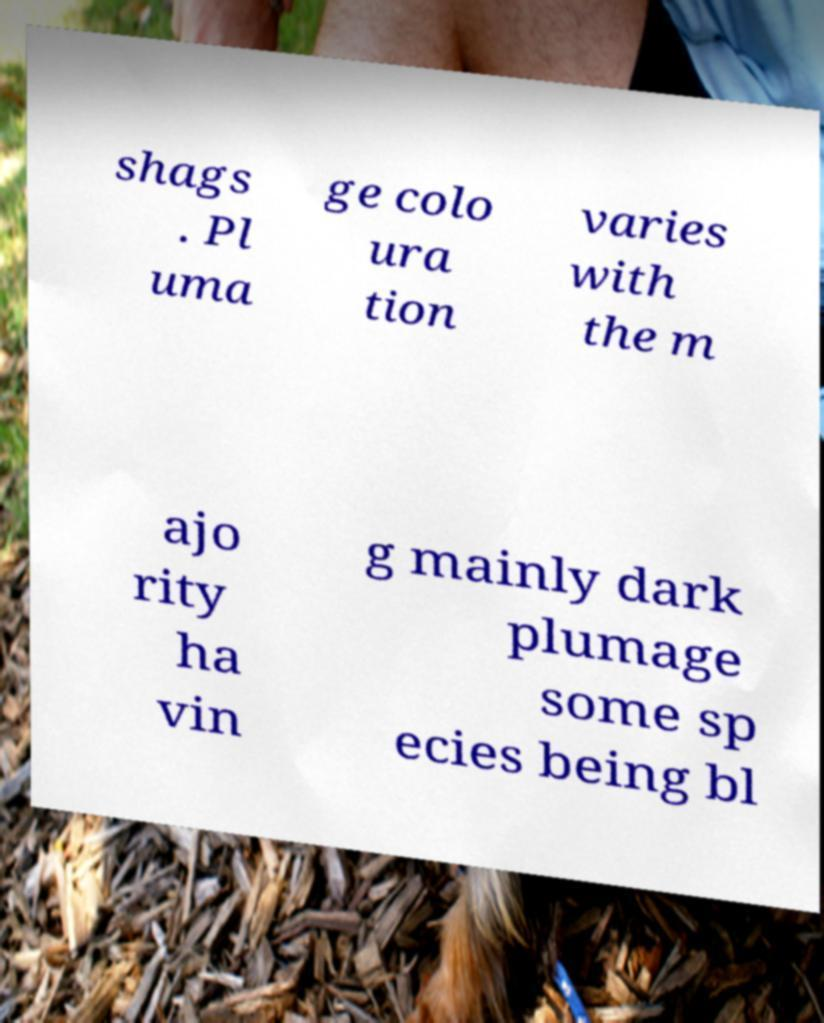Could you assist in decoding the text presented in this image and type it out clearly? shags . Pl uma ge colo ura tion varies with the m ajo rity ha vin g mainly dark plumage some sp ecies being bl 